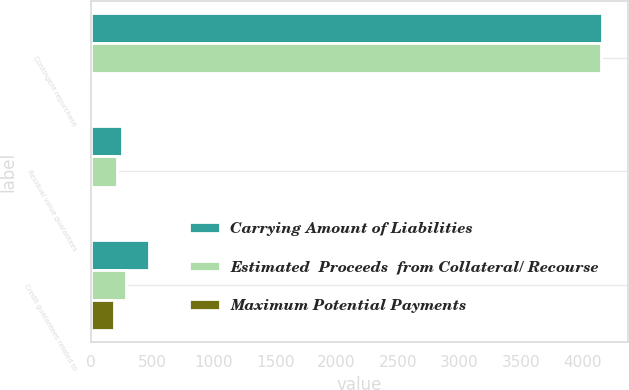Convert chart to OTSL. <chart><loc_0><loc_0><loc_500><loc_500><stacked_bar_chart><ecel><fcel>Contingent repurchase<fcel>Residual value guarantees<fcel>Credit guarantees related to<nl><fcel>Carrying Amount of Liabilities<fcel>4164<fcel>252<fcel>471<nl><fcel>Estimated  Proceeds  from Collateral/ Recourse<fcel>4155<fcel>215<fcel>283<nl><fcel>Maximum Potential Payments<fcel>7<fcel>15<fcel>188<nl></chart> 